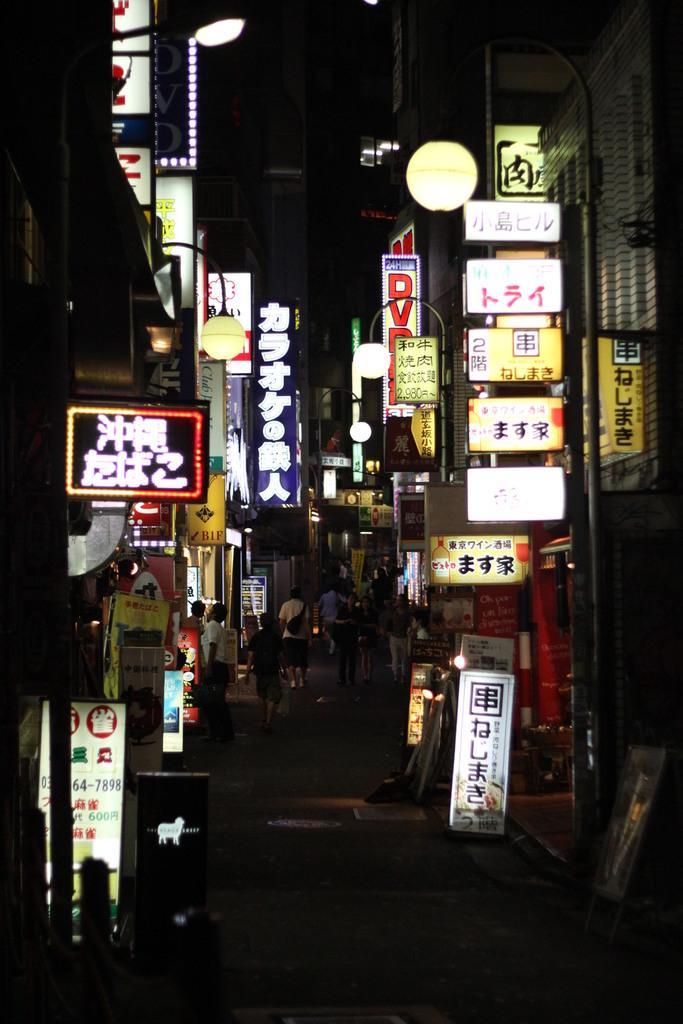Please provide a concise description of this image. In this picture I can see many buildings, posters, banners, advertisement boards and other objects. At the bottom I can see some people were standing near to the shop. At the top I can see the darkness. At the bottom there is a road. 